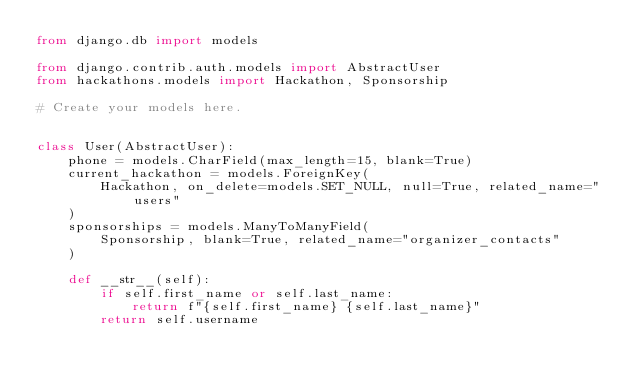Convert code to text. <code><loc_0><loc_0><loc_500><loc_500><_Python_>from django.db import models

from django.contrib.auth.models import AbstractUser
from hackathons.models import Hackathon, Sponsorship

# Create your models here.


class User(AbstractUser):
    phone = models.CharField(max_length=15, blank=True)
    current_hackathon = models.ForeignKey(
        Hackathon, on_delete=models.SET_NULL, null=True, related_name="users"
    )
    sponsorships = models.ManyToManyField(
        Sponsorship, blank=True, related_name="organizer_contacts"
    )

    def __str__(self):
        if self.first_name or self.last_name:
            return f"{self.first_name} {self.last_name}"
        return self.username</code> 